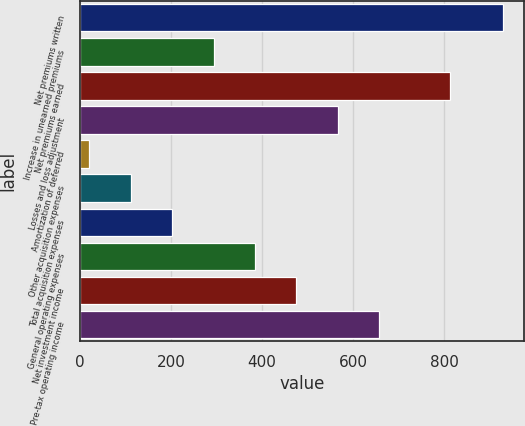Convert chart to OTSL. <chart><loc_0><loc_0><loc_500><loc_500><bar_chart><fcel>Net premiums written<fcel>Increase in unearned premiums<fcel>Net premiums earned<fcel>Losses and loss adjustment<fcel>Amortization of deferred<fcel>Other acquisition expenses<fcel>Total acquisition expenses<fcel>General operating expenses<fcel>Net investment income<fcel>Pre-tax operating income<nl><fcel>929<fcel>293.4<fcel>812<fcel>565.8<fcel>21<fcel>111.8<fcel>202.6<fcel>384.2<fcel>475<fcel>656.6<nl></chart> 